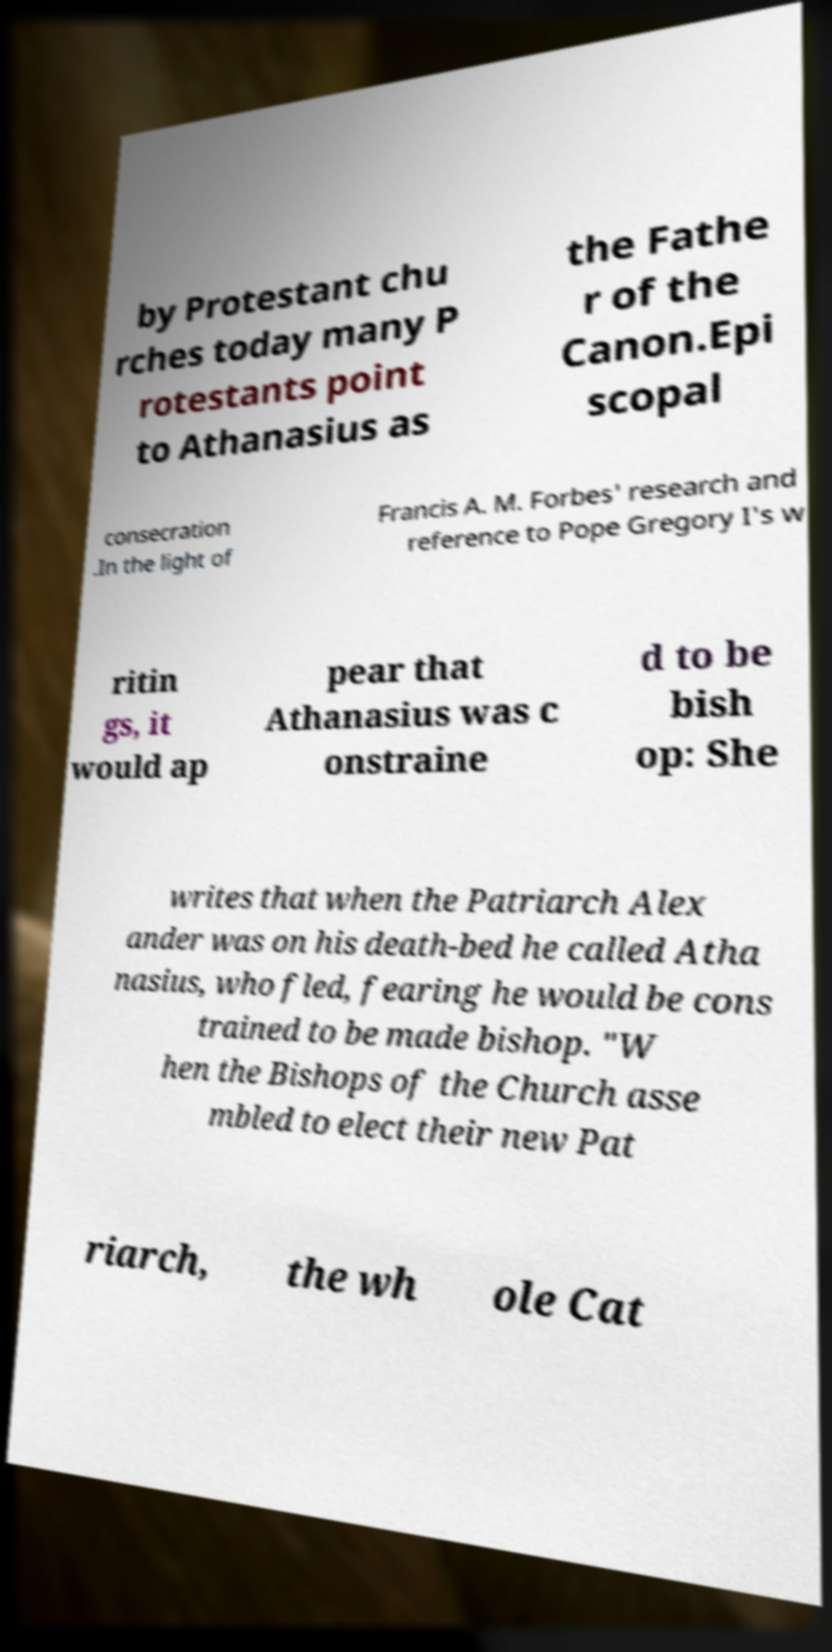For documentation purposes, I need the text within this image transcribed. Could you provide that? by Protestant chu rches today many P rotestants point to Athanasius as the Fathe r of the Canon.Epi scopal consecration .In the light of Francis A. M. Forbes' research and reference to Pope Gregory I's w ritin gs, it would ap pear that Athanasius was c onstraine d to be bish op: She writes that when the Patriarch Alex ander was on his death-bed he called Atha nasius, who fled, fearing he would be cons trained to be made bishop. "W hen the Bishops of the Church asse mbled to elect their new Pat riarch, the wh ole Cat 